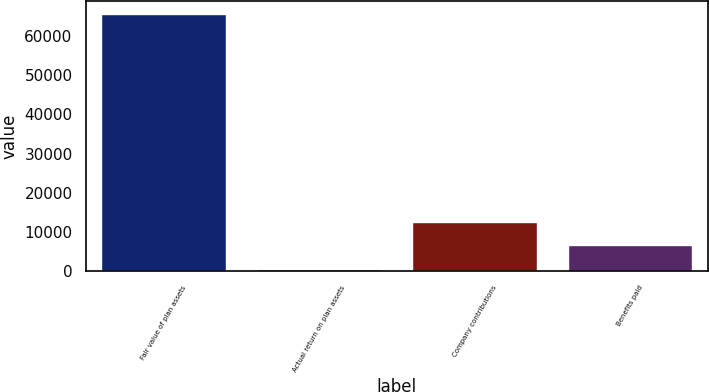<chart> <loc_0><loc_0><loc_500><loc_500><bar_chart><fcel>Fair value of plan assets<fcel>Actual return on plan assets<fcel>Company contributions<fcel>Benefits paid<nl><fcel>65551<fcel>611<fcel>12577<fcel>6594<nl></chart> 